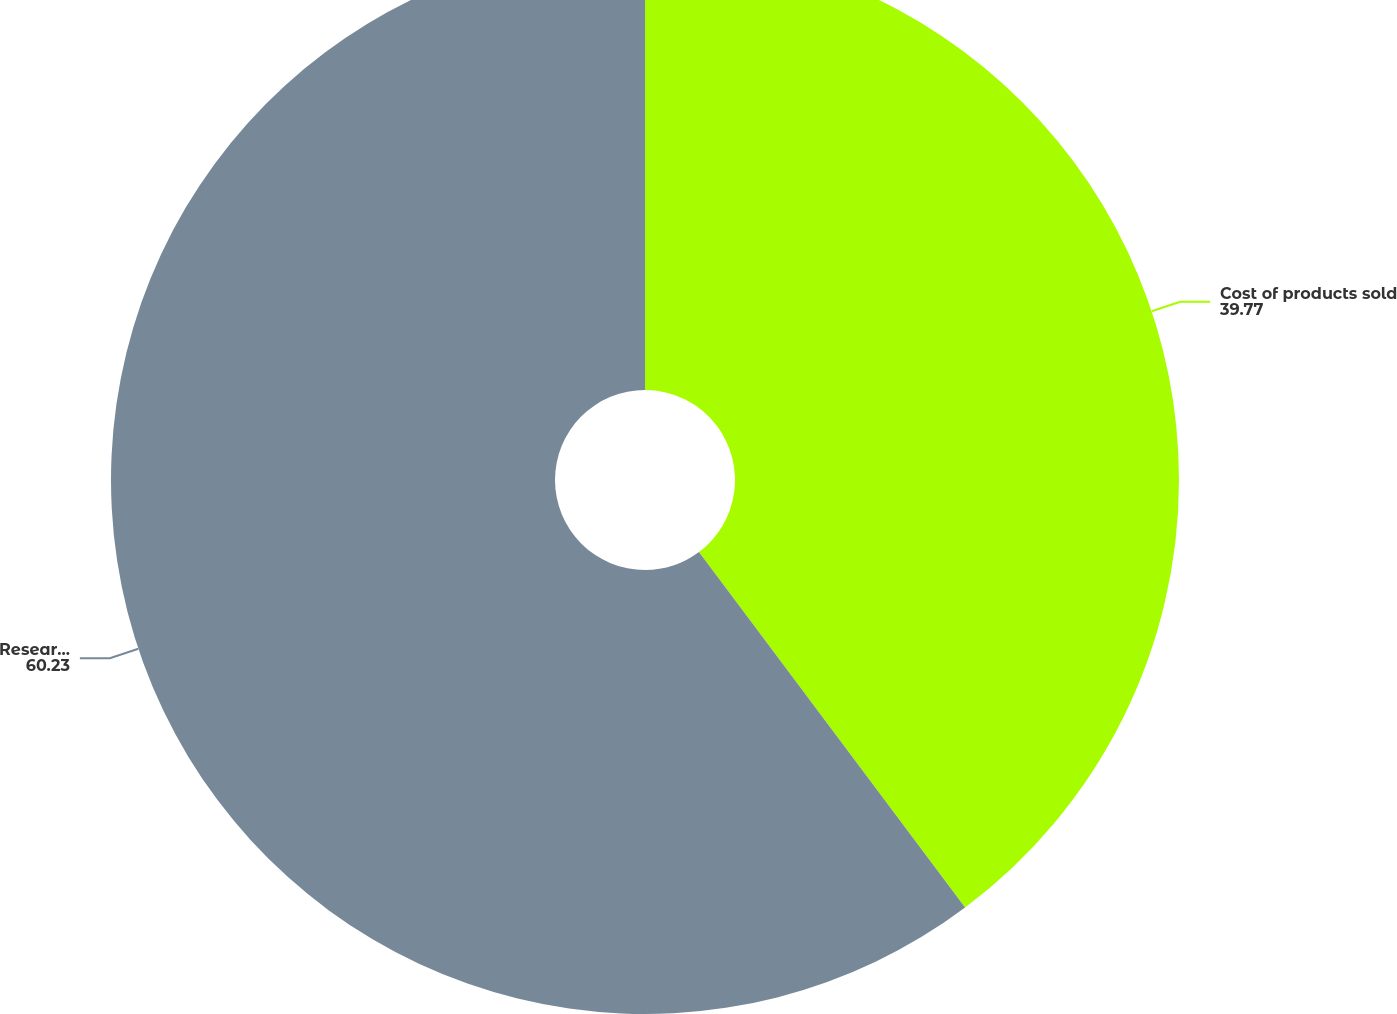Convert chart to OTSL. <chart><loc_0><loc_0><loc_500><loc_500><pie_chart><fcel>Cost of products sold<fcel>Research and development<nl><fcel>39.77%<fcel>60.23%<nl></chart> 